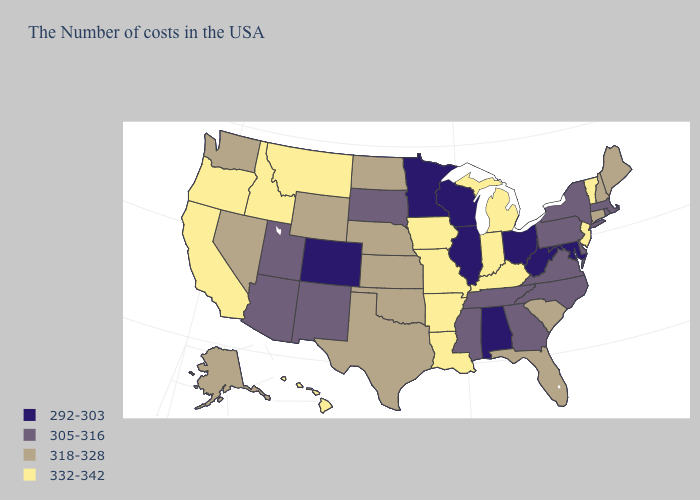Name the states that have a value in the range 332-342?
Keep it brief. Vermont, New Jersey, Michigan, Kentucky, Indiana, Louisiana, Missouri, Arkansas, Iowa, Montana, Idaho, California, Oregon, Hawaii. Does the map have missing data?
Short answer required. No. Among the states that border California , does Arizona have the lowest value?
Answer briefly. Yes. Does Minnesota have the lowest value in the USA?
Concise answer only. Yes. Does the first symbol in the legend represent the smallest category?
Give a very brief answer. Yes. Among the states that border Maine , which have the highest value?
Give a very brief answer. New Hampshire. What is the lowest value in the MidWest?
Give a very brief answer. 292-303. Among the states that border Vermont , does Massachusetts have the lowest value?
Keep it brief. Yes. Does Illinois have the lowest value in the MidWest?
Short answer required. Yes. What is the value of Ohio?
Keep it brief. 292-303. Name the states that have a value in the range 305-316?
Give a very brief answer. Massachusetts, Rhode Island, New York, Delaware, Pennsylvania, Virginia, North Carolina, Georgia, Tennessee, Mississippi, South Dakota, New Mexico, Utah, Arizona. Name the states that have a value in the range 332-342?
Write a very short answer. Vermont, New Jersey, Michigan, Kentucky, Indiana, Louisiana, Missouri, Arkansas, Iowa, Montana, Idaho, California, Oregon, Hawaii. Does Wisconsin have the lowest value in the USA?
Quick response, please. Yes. Does the first symbol in the legend represent the smallest category?
Give a very brief answer. Yes. Does Texas have the lowest value in the USA?
Write a very short answer. No. 